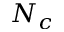Convert formula to latex. <formula><loc_0><loc_0><loc_500><loc_500>N _ { c }</formula> 